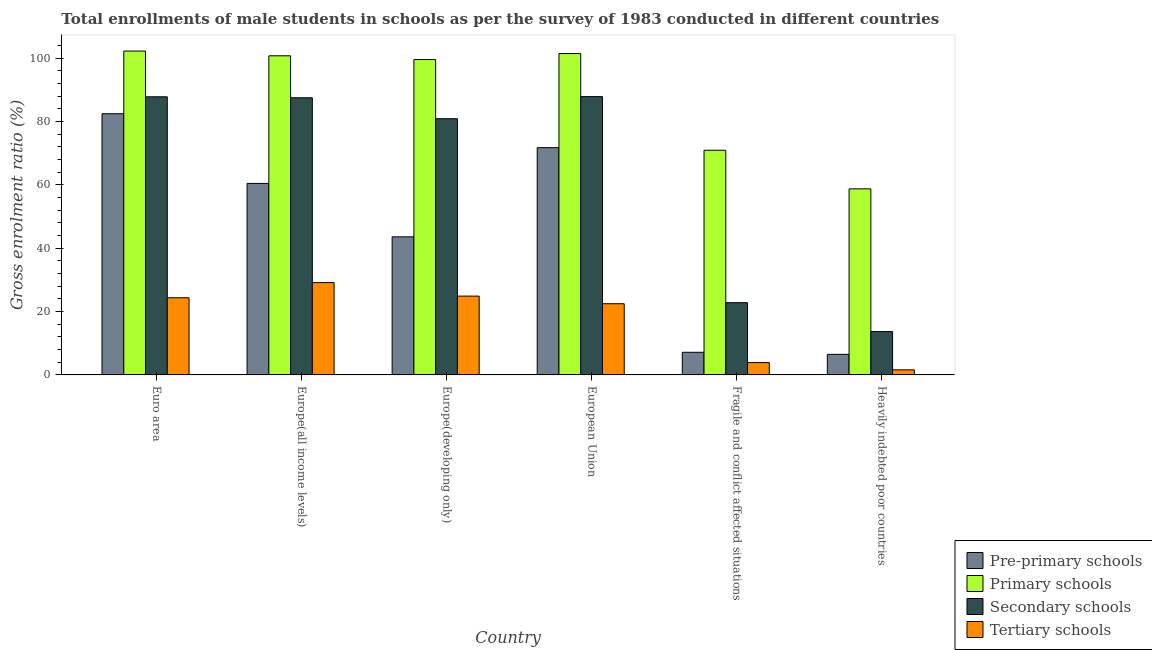How many different coloured bars are there?
Keep it short and to the point. 4. How many groups of bars are there?
Provide a succinct answer. 6. Are the number of bars on each tick of the X-axis equal?
Provide a short and direct response. Yes. How many bars are there on the 2nd tick from the left?
Provide a short and direct response. 4. What is the gross enrolment ratio(male) in pre-primary schools in Europe(all income levels)?
Provide a short and direct response. 60.44. Across all countries, what is the maximum gross enrolment ratio(male) in tertiary schools?
Provide a short and direct response. 29.13. Across all countries, what is the minimum gross enrolment ratio(male) in secondary schools?
Provide a short and direct response. 13.68. In which country was the gross enrolment ratio(male) in pre-primary schools maximum?
Ensure brevity in your answer.  Euro area. In which country was the gross enrolment ratio(male) in tertiary schools minimum?
Offer a very short reply. Heavily indebted poor countries. What is the total gross enrolment ratio(male) in primary schools in the graph?
Make the answer very short. 533.57. What is the difference between the gross enrolment ratio(male) in pre-primary schools in Euro area and that in Fragile and conflict affected situations?
Keep it short and to the point. 75.3. What is the difference between the gross enrolment ratio(male) in secondary schools in Euro area and the gross enrolment ratio(male) in primary schools in Europe(all income levels)?
Ensure brevity in your answer.  -12.94. What is the average gross enrolment ratio(male) in tertiary schools per country?
Your response must be concise. 17.72. What is the difference between the gross enrolment ratio(male) in secondary schools and gross enrolment ratio(male) in primary schools in Euro area?
Provide a succinct answer. -14.43. What is the ratio of the gross enrolment ratio(male) in secondary schools in Euro area to that in Fragile and conflict affected situations?
Your response must be concise. 3.85. What is the difference between the highest and the second highest gross enrolment ratio(male) in tertiary schools?
Offer a very short reply. 4.26. What is the difference between the highest and the lowest gross enrolment ratio(male) in secondary schools?
Give a very brief answer. 74.16. What does the 3rd bar from the left in Euro area represents?
Give a very brief answer. Secondary schools. What does the 4th bar from the right in Heavily indebted poor countries represents?
Keep it short and to the point. Pre-primary schools. How many bars are there?
Give a very brief answer. 24. Are all the bars in the graph horizontal?
Offer a very short reply. No. What is the difference between two consecutive major ticks on the Y-axis?
Keep it short and to the point. 20. Are the values on the major ticks of Y-axis written in scientific E-notation?
Give a very brief answer. No. Does the graph contain any zero values?
Give a very brief answer. No. Does the graph contain grids?
Your response must be concise. No. Where does the legend appear in the graph?
Your answer should be very brief. Bottom right. How many legend labels are there?
Your answer should be very brief. 4. What is the title of the graph?
Ensure brevity in your answer.  Total enrollments of male students in schools as per the survey of 1983 conducted in different countries. What is the label or title of the X-axis?
Provide a succinct answer. Country. What is the Gross enrolment ratio (%) of Pre-primary schools in Euro area?
Give a very brief answer. 82.45. What is the Gross enrolment ratio (%) of Primary schools in Euro area?
Make the answer very short. 102.22. What is the Gross enrolment ratio (%) of Secondary schools in Euro area?
Offer a very short reply. 87.79. What is the Gross enrolment ratio (%) in Tertiary schools in Euro area?
Your response must be concise. 24.35. What is the Gross enrolment ratio (%) of Pre-primary schools in Europe(all income levels)?
Keep it short and to the point. 60.44. What is the Gross enrolment ratio (%) of Primary schools in Europe(all income levels)?
Your answer should be very brief. 100.73. What is the Gross enrolment ratio (%) of Secondary schools in Europe(all income levels)?
Offer a terse response. 87.47. What is the Gross enrolment ratio (%) of Tertiary schools in Europe(all income levels)?
Provide a succinct answer. 29.13. What is the Gross enrolment ratio (%) of Pre-primary schools in Europe(developing only)?
Give a very brief answer. 43.58. What is the Gross enrolment ratio (%) of Primary schools in Europe(developing only)?
Make the answer very short. 99.54. What is the Gross enrolment ratio (%) of Secondary schools in Europe(developing only)?
Give a very brief answer. 80.87. What is the Gross enrolment ratio (%) of Tertiary schools in Europe(developing only)?
Ensure brevity in your answer.  24.88. What is the Gross enrolment ratio (%) of Pre-primary schools in European Union?
Make the answer very short. 71.73. What is the Gross enrolment ratio (%) of Primary schools in European Union?
Provide a succinct answer. 101.43. What is the Gross enrolment ratio (%) of Secondary schools in European Union?
Provide a short and direct response. 87.84. What is the Gross enrolment ratio (%) of Tertiary schools in European Union?
Your answer should be very brief. 22.47. What is the Gross enrolment ratio (%) of Pre-primary schools in Fragile and conflict affected situations?
Your response must be concise. 7.14. What is the Gross enrolment ratio (%) of Primary schools in Fragile and conflict affected situations?
Ensure brevity in your answer.  70.91. What is the Gross enrolment ratio (%) of Secondary schools in Fragile and conflict affected situations?
Make the answer very short. 22.8. What is the Gross enrolment ratio (%) of Tertiary schools in Fragile and conflict affected situations?
Offer a terse response. 3.89. What is the Gross enrolment ratio (%) in Pre-primary schools in Heavily indebted poor countries?
Offer a very short reply. 6.49. What is the Gross enrolment ratio (%) in Primary schools in Heavily indebted poor countries?
Your answer should be compact. 58.73. What is the Gross enrolment ratio (%) in Secondary schools in Heavily indebted poor countries?
Your response must be concise. 13.68. What is the Gross enrolment ratio (%) of Tertiary schools in Heavily indebted poor countries?
Give a very brief answer. 1.6. Across all countries, what is the maximum Gross enrolment ratio (%) of Pre-primary schools?
Provide a short and direct response. 82.45. Across all countries, what is the maximum Gross enrolment ratio (%) in Primary schools?
Ensure brevity in your answer.  102.22. Across all countries, what is the maximum Gross enrolment ratio (%) in Secondary schools?
Your answer should be compact. 87.84. Across all countries, what is the maximum Gross enrolment ratio (%) of Tertiary schools?
Provide a short and direct response. 29.13. Across all countries, what is the minimum Gross enrolment ratio (%) in Pre-primary schools?
Keep it short and to the point. 6.49. Across all countries, what is the minimum Gross enrolment ratio (%) of Primary schools?
Offer a very short reply. 58.73. Across all countries, what is the minimum Gross enrolment ratio (%) in Secondary schools?
Keep it short and to the point. 13.68. Across all countries, what is the minimum Gross enrolment ratio (%) of Tertiary schools?
Make the answer very short. 1.6. What is the total Gross enrolment ratio (%) of Pre-primary schools in the graph?
Offer a terse response. 271.83. What is the total Gross enrolment ratio (%) in Primary schools in the graph?
Offer a terse response. 533.57. What is the total Gross enrolment ratio (%) of Secondary schools in the graph?
Provide a short and direct response. 380.45. What is the total Gross enrolment ratio (%) of Tertiary schools in the graph?
Offer a terse response. 106.33. What is the difference between the Gross enrolment ratio (%) in Pre-primary schools in Euro area and that in Europe(all income levels)?
Give a very brief answer. 22. What is the difference between the Gross enrolment ratio (%) in Primary schools in Euro area and that in Europe(all income levels)?
Provide a short and direct response. 1.49. What is the difference between the Gross enrolment ratio (%) of Secondary schools in Euro area and that in Europe(all income levels)?
Keep it short and to the point. 0.31. What is the difference between the Gross enrolment ratio (%) of Tertiary schools in Euro area and that in Europe(all income levels)?
Keep it short and to the point. -4.78. What is the difference between the Gross enrolment ratio (%) of Pre-primary schools in Euro area and that in Europe(developing only)?
Offer a terse response. 38.86. What is the difference between the Gross enrolment ratio (%) of Primary schools in Euro area and that in Europe(developing only)?
Offer a terse response. 2.67. What is the difference between the Gross enrolment ratio (%) of Secondary schools in Euro area and that in Europe(developing only)?
Your answer should be compact. 6.92. What is the difference between the Gross enrolment ratio (%) in Tertiary schools in Euro area and that in Europe(developing only)?
Your answer should be compact. -0.52. What is the difference between the Gross enrolment ratio (%) in Pre-primary schools in Euro area and that in European Union?
Give a very brief answer. 10.72. What is the difference between the Gross enrolment ratio (%) in Primary schools in Euro area and that in European Union?
Offer a very short reply. 0.78. What is the difference between the Gross enrolment ratio (%) of Secondary schools in Euro area and that in European Union?
Offer a very short reply. -0.05. What is the difference between the Gross enrolment ratio (%) in Tertiary schools in Euro area and that in European Union?
Offer a very short reply. 1.88. What is the difference between the Gross enrolment ratio (%) of Pre-primary schools in Euro area and that in Fragile and conflict affected situations?
Provide a succinct answer. 75.3. What is the difference between the Gross enrolment ratio (%) in Primary schools in Euro area and that in Fragile and conflict affected situations?
Offer a very short reply. 31.31. What is the difference between the Gross enrolment ratio (%) of Secondary schools in Euro area and that in Fragile and conflict affected situations?
Ensure brevity in your answer.  64.98. What is the difference between the Gross enrolment ratio (%) in Tertiary schools in Euro area and that in Fragile and conflict affected situations?
Provide a succinct answer. 20.46. What is the difference between the Gross enrolment ratio (%) in Pre-primary schools in Euro area and that in Heavily indebted poor countries?
Your response must be concise. 75.95. What is the difference between the Gross enrolment ratio (%) in Primary schools in Euro area and that in Heavily indebted poor countries?
Your response must be concise. 43.49. What is the difference between the Gross enrolment ratio (%) in Secondary schools in Euro area and that in Heavily indebted poor countries?
Offer a very short reply. 74.11. What is the difference between the Gross enrolment ratio (%) of Tertiary schools in Euro area and that in Heavily indebted poor countries?
Give a very brief answer. 22.75. What is the difference between the Gross enrolment ratio (%) of Pre-primary schools in Europe(all income levels) and that in Europe(developing only)?
Provide a short and direct response. 16.86. What is the difference between the Gross enrolment ratio (%) of Primary schools in Europe(all income levels) and that in Europe(developing only)?
Keep it short and to the point. 1.19. What is the difference between the Gross enrolment ratio (%) in Secondary schools in Europe(all income levels) and that in Europe(developing only)?
Your response must be concise. 6.61. What is the difference between the Gross enrolment ratio (%) in Tertiary schools in Europe(all income levels) and that in Europe(developing only)?
Your answer should be very brief. 4.26. What is the difference between the Gross enrolment ratio (%) of Pre-primary schools in Europe(all income levels) and that in European Union?
Make the answer very short. -11.28. What is the difference between the Gross enrolment ratio (%) of Primary schools in Europe(all income levels) and that in European Union?
Ensure brevity in your answer.  -0.7. What is the difference between the Gross enrolment ratio (%) of Secondary schools in Europe(all income levels) and that in European Union?
Offer a terse response. -0.37. What is the difference between the Gross enrolment ratio (%) in Tertiary schools in Europe(all income levels) and that in European Union?
Your response must be concise. 6.66. What is the difference between the Gross enrolment ratio (%) in Pre-primary schools in Europe(all income levels) and that in Fragile and conflict affected situations?
Ensure brevity in your answer.  53.3. What is the difference between the Gross enrolment ratio (%) in Primary schools in Europe(all income levels) and that in Fragile and conflict affected situations?
Give a very brief answer. 29.82. What is the difference between the Gross enrolment ratio (%) of Secondary schools in Europe(all income levels) and that in Fragile and conflict affected situations?
Ensure brevity in your answer.  64.67. What is the difference between the Gross enrolment ratio (%) of Tertiary schools in Europe(all income levels) and that in Fragile and conflict affected situations?
Your answer should be compact. 25.25. What is the difference between the Gross enrolment ratio (%) in Pre-primary schools in Europe(all income levels) and that in Heavily indebted poor countries?
Keep it short and to the point. 53.95. What is the difference between the Gross enrolment ratio (%) in Primary schools in Europe(all income levels) and that in Heavily indebted poor countries?
Offer a very short reply. 42. What is the difference between the Gross enrolment ratio (%) of Secondary schools in Europe(all income levels) and that in Heavily indebted poor countries?
Make the answer very short. 73.79. What is the difference between the Gross enrolment ratio (%) of Tertiary schools in Europe(all income levels) and that in Heavily indebted poor countries?
Make the answer very short. 27.53. What is the difference between the Gross enrolment ratio (%) of Pre-primary schools in Europe(developing only) and that in European Union?
Offer a very short reply. -28.14. What is the difference between the Gross enrolment ratio (%) of Primary schools in Europe(developing only) and that in European Union?
Offer a terse response. -1.89. What is the difference between the Gross enrolment ratio (%) in Secondary schools in Europe(developing only) and that in European Union?
Provide a succinct answer. -6.97. What is the difference between the Gross enrolment ratio (%) in Tertiary schools in Europe(developing only) and that in European Union?
Keep it short and to the point. 2.41. What is the difference between the Gross enrolment ratio (%) in Pre-primary schools in Europe(developing only) and that in Fragile and conflict affected situations?
Keep it short and to the point. 36.44. What is the difference between the Gross enrolment ratio (%) in Primary schools in Europe(developing only) and that in Fragile and conflict affected situations?
Offer a terse response. 28.63. What is the difference between the Gross enrolment ratio (%) of Secondary schools in Europe(developing only) and that in Fragile and conflict affected situations?
Your response must be concise. 58.07. What is the difference between the Gross enrolment ratio (%) of Tertiary schools in Europe(developing only) and that in Fragile and conflict affected situations?
Your response must be concise. 20.99. What is the difference between the Gross enrolment ratio (%) of Pre-primary schools in Europe(developing only) and that in Heavily indebted poor countries?
Give a very brief answer. 37.09. What is the difference between the Gross enrolment ratio (%) in Primary schools in Europe(developing only) and that in Heavily indebted poor countries?
Make the answer very short. 40.82. What is the difference between the Gross enrolment ratio (%) of Secondary schools in Europe(developing only) and that in Heavily indebted poor countries?
Your answer should be very brief. 67.19. What is the difference between the Gross enrolment ratio (%) of Tertiary schools in Europe(developing only) and that in Heavily indebted poor countries?
Your answer should be compact. 23.27. What is the difference between the Gross enrolment ratio (%) of Pre-primary schools in European Union and that in Fragile and conflict affected situations?
Offer a terse response. 64.58. What is the difference between the Gross enrolment ratio (%) in Primary schools in European Union and that in Fragile and conflict affected situations?
Give a very brief answer. 30.52. What is the difference between the Gross enrolment ratio (%) of Secondary schools in European Union and that in Fragile and conflict affected situations?
Make the answer very short. 65.04. What is the difference between the Gross enrolment ratio (%) of Tertiary schools in European Union and that in Fragile and conflict affected situations?
Your answer should be compact. 18.58. What is the difference between the Gross enrolment ratio (%) in Pre-primary schools in European Union and that in Heavily indebted poor countries?
Offer a terse response. 65.24. What is the difference between the Gross enrolment ratio (%) in Primary schools in European Union and that in Heavily indebted poor countries?
Make the answer very short. 42.71. What is the difference between the Gross enrolment ratio (%) of Secondary schools in European Union and that in Heavily indebted poor countries?
Your answer should be very brief. 74.16. What is the difference between the Gross enrolment ratio (%) of Tertiary schools in European Union and that in Heavily indebted poor countries?
Ensure brevity in your answer.  20.87. What is the difference between the Gross enrolment ratio (%) in Pre-primary schools in Fragile and conflict affected situations and that in Heavily indebted poor countries?
Your answer should be very brief. 0.65. What is the difference between the Gross enrolment ratio (%) of Primary schools in Fragile and conflict affected situations and that in Heavily indebted poor countries?
Keep it short and to the point. 12.18. What is the difference between the Gross enrolment ratio (%) of Secondary schools in Fragile and conflict affected situations and that in Heavily indebted poor countries?
Give a very brief answer. 9.12. What is the difference between the Gross enrolment ratio (%) in Tertiary schools in Fragile and conflict affected situations and that in Heavily indebted poor countries?
Provide a short and direct response. 2.28. What is the difference between the Gross enrolment ratio (%) in Pre-primary schools in Euro area and the Gross enrolment ratio (%) in Primary schools in Europe(all income levels)?
Provide a short and direct response. -18.29. What is the difference between the Gross enrolment ratio (%) of Pre-primary schools in Euro area and the Gross enrolment ratio (%) of Secondary schools in Europe(all income levels)?
Give a very brief answer. -5.03. What is the difference between the Gross enrolment ratio (%) of Pre-primary schools in Euro area and the Gross enrolment ratio (%) of Tertiary schools in Europe(all income levels)?
Provide a succinct answer. 53.31. What is the difference between the Gross enrolment ratio (%) in Primary schools in Euro area and the Gross enrolment ratio (%) in Secondary schools in Europe(all income levels)?
Your answer should be very brief. 14.74. What is the difference between the Gross enrolment ratio (%) of Primary schools in Euro area and the Gross enrolment ratio (%) of Tertiary schools in Europe(all income levels)?
Offer a very short reply. 73.08. What is the difference between the Gross enrolment ratio (%) in Secondary schools in Euro area and the Gross enrolment ratio (%) in Tertiary schools in Europe(all income levels)?
Offer a very short reply. 58.65. What is the difference between the Gross enrolment ratio (%) of Pre-primary schools in Euro area and the Gross enrolment ratio (%) of Primary schools in Europe(developing only)?
Your response must be concise. -17.1. What is the difference between the Gross enrolment ratio (%) of Pre-primary schools in Euro area and the Gross enrolment ratio (%) of Secondary schools in Europe(developing only)?
Offer a very short reply. 1.58. What is the difference between the Gross enrolment ratio (%) of Pre-primary schools in Euro area and the Gross enrolment ratio (%) of Tertiary schools in Europe(developing only)?
Your answer should be very brief. 57.57. What is the difference between the Gross enrolment ratio (%) in Primary schools in Euro area and the Gross enrolment ratio (%) in Secondary schools in Europe(developing only)?
Offer a terse response. 21.35. What is the difference between the Gross enrolment ratio (%) in Primary schools in Euro area and the Gross enrolment ratio (%) in Tertiary schools in Europe(developing only)?
Your response must be concise. 77.34. What is the difference between the Gross enrolment ratio (%) of Secondary schools in Euro area and the Gross enrolment ratio (%) of Tertiary schools in Europe(developing only)?
Provide a succinct answer. 62.91. What is the difference between the Gross enrolment ratio (%) in Pre-primary schools in Euro area and the Gross enrolment ratio (%) in Primary schools in European Union?
Your answer should be compact. -18.99. What is the difference between the Gross enrolment ratio (%) of Pre-primary schools in Euro area and the Gross enrolment ratio (%) of Secondary schools in European Union?
Provide a succinct answer. -5.39. What is the difference between the Gross enrolment ratio (%) of Pre-primary schools in Euro area and the Gross enrolment ratio (%) of Tertiary schools in European Union?
Your answer should be compact. 59.97. What is the difference between the Gross enrolment ratio (%) of Primary schools in Euro area and the Gross enrolment ratio (%) of Secondary schools in European Union?
Your answer should be very brief. 14.38. What is the difference between the Gross enrolment ratio (%) of Primary schools in Euro area and the Gross enrolment ratio (%) of Tertiary schools in European Union?
Give a very brief answer. 79.75. What is the difference between the Gross enrolment ratio (%) of Secondary schools in Euro area and the Gross enrolment ratio (%) of Tertiary schools in European Union?
Make the answer very short. 65.31. What is the difference between the Gross enrolment ratio (%) of Pre-primary schools in Euro area and the Gross enrolment ratio (%) of Primary schools in Fragile and conflict affected situations?
Make the answer very short. 11.53. What is the difference between the Gross enrolment ratio (%) of Pre-primary schools in Euro area and the Gross enrolment ratio (%) of Secondary schools in Fragile and conflict affected situations?
Give a very brief answer. 59.64. What is the difference between the Gross enrolment ratio (%) of Pre-primary schools in Euro area and the Gross enrolment ratio (%) of Tertiary schools in Fragile and conflict affected situations?
Your response must be concise. 78.56. What is the difference between the Gross enrolment ratio (%) of Primary schools in Euro area and the Gross enrolment ratio (%) of Secondary schools in Fragile and conflict affected situations?
Ensure brevity in your answer.  79.42. What is the difference between the Gross enrolment ratio (%) of Primary schools in Euro area and the Gross enrolment ratio (%) of Tertiary schools in Fragile and conflict affected situations?
Your answer should be very brief. 98.33. What is the difference between the Gross enrolment ratio (%) in Secondary schools in Euro area and the Gross enrolment ratio (%) in Tertiary schools in Fragile and conflict affected situations?
Give a very brief answer. 83.9. What is the difference between the Gross enrolment ratio (%) of Pre-primary schools in Euro area and the Gross enrolment ratio (%) of Primary schools in Heavily indebted poor countries?
Offer a very short reply. 23.72. What is the difference between the Gross enrolment ratio (%) in Pre-primary schools in Euro area and the Gross enrolment ratio (%) in Secondary schools in Heavily indebted poor countries?
Make the answer very short. 68.77. What is the difference between the Gross enrolment ratio (%) in Pre-primary schools in Euro area and the Gross enrolment ratio (%) in Tertiary schools in Heavily indebted poor countries?
Your answer should be compact. 80.84. What is the difference between the Gross enrolment ratio (%) in Primary schools in Euro area and the Gross enrolment ratio (%) in Secondary schools in Heavily indebted poor countries?
Give a very brief answer. 88.54. What is the difference between the Gross enrolment ratio (%) of Primary schools in Euro area and the Gross enrolment ratio (%) of Tertiary schools in Heavily indebted poor countries?
Provide a succinct answer. 100.61. What is the difference between the Gross enrolment ratio (%) in Secondary schools in Euro area and the Gross enrolment ratio (%) in Tertiary schools in Heavily indebted poor countries?
Provide a short and direct response. 86.18. What is the difference between the Gross enrolment ratio (%) of Pre-primary schools in Europe(all income levels) and the Gross enrolment ratio (%) of Primary schools in Europe(developing only)?
Offer a very short reply. -39.1. What is the difference between the Gross enrolment ratio (%) of Pre-primary schools in Europe(all income levels) and the Gross enrolment ratio (%) of Secondary schools in Europe(developing only)?
Your response must be concise. -20.42. What is the difference between the Gross enrolment ratio (%) of Pre-primary schools in Europe(all income levels) and the Gross enrolment ratio (%) of Tertiary schools in Europe(developing only)?
Your answer should be compact. 35.57. What is the difference between the Gross enrolment ratio (%) of Primary schools in Europe(all income levels) and the Gross enrolment ratio (%) of Secondary schools in Europe(developing only)?
Offer a terse response. 19.86. What is the difference between the Gross enrolment ratio (%) of Primary schools in Europe(all income levels) and the Gross enrolment ratio (%) of Tertiary schools in Europe(developing only)?
Ensure brevity in your answer.  75.85. What is the difference between the Gross enrolment ratio (%) in Secondary schools in Europe(all income levels) and the Gross enrolment ratio (%) in Tertiary schools in Europe(developing only)?
Your answer should be compact. 62.6. What is the difference between the Gross enrolment ratio (%) in Pre-primary schools in Europe(all income levels) and the Gross enrolment ratio (%) in Primary schools in European Union?
Offer a terse response. -40.99. What is the difference between the Gross enrolment ratio (%) of Pre-primary schools in Europe(all income levels) and the Gross enrolment ratio (%) of Secondary schools in European Union?
Provide a short and direct response. -27.39. What is the difference between the Gross enrolment ratio (%) of Pre-primary schools in Europe(all income levels) and the Gross enrolment ratio (%) of Tertiary schools in European Union?
Offer a terse response. 37.97. What is the difference between the Gross enrolment ratio (%) in Primary schools in Europe(all income levels) and the Gross enrolment ratio (%) in Secondary schools in European Union?
Provide a succinct answer. 12.89. What is the difference between the Gross enrolment ratio (%) of Primary schools in Europe(all income levels) and the Gross enrolment ratio (%) of Tertiary schools in European Union?
Ensure brevity in your answer.  78.26. What is the difference between the Gross enrolment ratio (%) of Secondary schools in Europe(all income levels) and the Gross enrolment ratio (%) of Tertiary schools in European Union?
Offer a very short reply. 65. What is the difference between the Gross enrolment ratio (%) in Pre-primary schools in Europe(all income levels) and the Gross enrolment ratio (%) in Primary schools in Fragile and conflict affected situations?
Give a very brief answer. -10.47. What is the difference between the Gross enrolment ratio (%) of Pre-primary schools in Europe(all income levels) and the Gross enrolment ratio (%) of Secondary schools in Fragile and conflict affected situations?
Provide a succinct answer. 37.64. What is the difference between the Gross enrolment ratio (%) in Pre-primary schools in Europe(all income levels) and the Gross enrolment ratio (%) in Tertiary schools in Fragile and conflict affected situations?
Provide a succinct answer. 56.56. What is the difference between the Gross enrolment ratio (%) in Primary schools in Europe(all income levels) and the Gross enrolment ratio (%) in Secondary schools in Fragile and conflict affected situations?
Provide a short and direct response. 77.93. What is the difference between the Gross enrolment ratio (%) in Primary schools in Europe(all income levels) and the Gross enrolment ratio (%) in Tertiary schools in Fragile and conflict affected situations?
Your answer should be very brief. 96.84. What is the difference between the Gross enrolment ratio (%) in Secondary schools in Europe(all income levels) and the Gross enrolment ratio (%) in Tertiary schools in Fragile and conflict affected situations?
Your response must be concise. 83.58. What is the difference between the Gross enrolment ratio (%) of Pre-primary schools in Europe(all income levels) and the Gross enrolment ratio (%) of Primary schools in Heavily indebted poor countries?
Offer a terse response. 1.72. What is the difference between the Gross enrolment ratio (%) of Pre-primary schools in Europe(all income levels) and the Gross enrolment ratio (%) of Secondary schools in Heavily indebted poor countries?
Make the answer very short. 46.76. What is the difference between the Gross enrolment ratio (%) in Pre-primary schools in Europe(all income levels) and the Gross enrolment ratio (%) in Tertiary schools in Heavily indebted poor countries?
Offer a terse response. 58.84. What is the difference between the Gross enrolment ratio (%) of Primary schools in Europe(all income levels) and the Gross enrolment ratio (%) of Secondary schools in Heavily indebted poor countries?
Provide a short and direct response. 87.05. What is the difference between the Gross enrolment ratio (%) of Primary schools in Europe(all income levels) and the Gross enrolment ratio (%) of Tertiary schools in Heavily indebted poor countries?
Offer a very short reply. 99.13. What is the difference between the Gross enrolment ratio (%) of Secondary schools in Europe(all income levels) and the Gross enrolment ratio (%) of Tertiary schools in Heavily indebted poor countries?
Ensure brevity in your answer.  85.87. What is the difference between the Gross enrolment ratio (%) in Pre-primary schools in Europe(developing only) and the Gross enrolment ratio (%) in Primary schools in European Union?
Offer a very short reply. -57.85. What is the difference between the Gross enrolment ratio (%) in Pre-primary schools in Europe(developing only) and the Gross enrolment ratio (%) in Secondary schools in European Union?
Provide a succinct answer. -44.26. What is the difference between the Gross enrolment ratio (%) in Pre-primary schools in Europe(developing only) and the Gross enrolment ratio (%) in Tertiary schools in European Union?
Your answer should be compact. 21.11. What is the difference between the Gross enrolment ratio (%) of Primary schools in Europe(developing only) and the Gross enrolment ratio (%) of Secondary schools in European Union?
Provide a succinct answer. 11.7. What is the difference between the Gross enrolment ratio (%) in Primary schools in Europe(developing only) and the Gross enrolment ratio (%) in Tertiary schools in European Union?
Provide a succinct answer. 77.07. What is the difference between the Gross enrolment ratio (%) of Secondary schools in Europe(developing only) and the Gross enrolment ratio (%) of Tertiary schools in European Union?
Your answer should be very brief. 58.4. What is the difference between the Gross enrolment ratio (%) of Pre-primary schools in Europe(developing only) and the Gross enrolment ratio (%) of Primary schools in Fragile and conflict affected situations?
Your answer should be compact. -27.33. What is the difference between the Gross enrolment ratio (%) of Pre-primary schools in Europe(developing only) and the Gross enrolment ratio (%) of Secondary schools in Fragile and conflict affected situations?
Ensure brevity in your answer.  20.78. What is the difference between the Gross enrolment ratio (%) of Pre-primary schools in Europe(developing only) and the Gross enrolment ratio (%) of Tertiary schools in Fragile and conflict affected situations?
Provide a succinct answer. 39.69. What is the difference between the Gross enrolment ratio (%) of Primary schools in Europe(developing only) and the Gross enrolment ratio (%) of Secondary schools in Fragile and conflict affected situations?
Offer a very short reply. 76.74. What is the difference between the Gross enrolment ratio (%) of Primary schools in Europe(developing only) and the Gross enrolment ratio (%) of Tertiary schools in Fragile and conflict affected situations?
Provide a short and direct response. 95.66. What is the difference between the Gross enrolment ratio (%) in Secondary schools in Europe(developing only) and the Gross enrolment ratio (%) in Tertiary schools in Fragile and conflict affected situations?
Provide a short and direct response. 76.98. What is the difference between the Gross enrolment ratio (%) of Pre-primary schools in Europe(developing only) and the Gross enrolment ratio (%) of Primary schools in Heavily indebted poor countries?
Offer a very short reply. -15.15. What is the difference between the Gross enrolment ratio (%) in Pre-primary schools in Europe(developing only) and the Gross enrolment ratio (%) in Secondary schools in Heavily indebted poor countries?
Provide a short and direct response. 29.9. What is the difference between the Gross enrolment ratio (%) of Pre-primary schools in Europe(developing only) and the Gross enrolment ratio (%) of Tertiary schools in Heavily indebted poor countries?
Offer a very short reply. 41.98. What is the difference between the Gross enrolment ratio (%) in Primary schools in Europe(developing only) and the Gross enrolment ratio (%) in Secondary schools in Heavily indebted poor countries?
Your answer should be compact. 85.86. What is the difference between the Gross enrolment ratio (%) in Primary schools in Europe(developing only) and the Gross enrolment ratio (%) in Tertiary schools in Heavily indebted poor countries?
Your answer should be very brief. 97.94. What is the difference between the Gross enrolment ratio (%) of Secondary schools in Europe(developing only) and the Gross enrolment ratio (%) of Tertiary schools in Heavily indebted poor countries?
Give a very brief answer. 79.26. What is the difference between the Gross enrolment ratio (%) in Pre-primary schools in European Union and the Gross enrolment ratio (%) in Primary schools in Fragile and conflict affected situations?
Your answer should be very brief. 0.82. What is the difference between the Gross enrolment ratio (%) of Pre-primary schools in European Union and the Gross enrolment ratio (%) of Secondary schools in Fragile and conflict affected situations?
Offer a very short reply. 48.93. What is the difference between the Gross enrolment ratio (%) in Pre-primary schools in European Union and the Gross enrolment ratio (%) in Tertiary schools in Fragile and conflict affected situations?
Offer a very short reply. 67.84. What is the difference between the Gross enrolment ratio (%) of Primary schools in European Union and the Gross enrolment ratio (%) of Secondary schools in Fragile and conflict affected situations?
Give a very brief answer. 78.63. What is the difference between the Gross enrolment ratio (%) of Primary schools in European Union and the Gross enrolment ratio (%) of Tertiary schools in Fragile and conflict affected situations?
Provide a short and direct response. 97.55. What is the difference between the Gross enrolment ratio (%) in Secondary schools in European Union and the Gross enrolment ratio (%) in Tertiary schools in Fragile and conflict affected situations?
Make the answer very short. 83.95. What is the difference between the Gross enrolment ratio (%) in Pre-primary schools in European Union and the Gross enrolment ratio (%) in Primary schools in Heavily indebted poor countries?
Your answer should be very brief. 13. What is the difference between the Gross enrolment ratio (%) in Pre-primary schools in European Union and the Gross enrolment ratio (%) in Secondary schools in Heavily indebted poor countries?
Your answer should be very brief. 58.05. What is the difference between the Gross enrolment ratio (%) in Pre-primary schools in European Union and the Gross enrolment ratio (%) in Tertiary schools in Heavily indebted poor countries?
Your response must be concise. 70.12. What is the difference between the Gross enrolment ratio (%) in Primary schools in European Union and the Gross enrolment ratio (%) in Secondary schools in Heavily indebted poor countries?
Provide a short and direct response. 87.75. What is the difference between the Gross enrolment ratio (%) of Primary schools in European Union and the Gross enrolment ratio (%) of Tertiary schools in Heavily indebted poor countries?
Give a very brief answer. 99.83. What is the difference between the Gross enrolment ratio (%) in Secondary schools in European Union and the Gross enrolment ratio (%) in Tertiary schools in Heavily indebted poor countries?
Ensure brevity in your answer.  86.24. What is the difference between the Gross enrolment ratio (%) of Pre-primary schools in Fragile and conflict affected situations and the Gross enrolment ratio (%) of Primary schools in Heavily indebted poor countries?
Provide a short and direct response. -51.59. What is the difference between the Gross enrolment ratio (%) of Pre-primary schools in Fragile and conflict affected situations and the Gross enrolment ratio (%) of Secondary schools in Heavily indebted poor countries?
Your response must be concise. -6.54. What is the difference between the Gross enrolment ratio (%) in Pre-primary schools in Fragile and conflict affected situations and the Gross enrolment ratio (%) in Tertiary schools in Heavily indebted poor countries?
Make the answer very short. 5.54. What is the difference between the Gross enrolment ratio (%) of Primary schools in Fragile and conflict affected situations and the Gross enrolment ratio (%) of Secondary schools in Heavily indebted poor countries?
Your response must be concise. 57.23. What is the difference between the Gross enrolment ratio (%) in Primary schools in Fragile and conflict affected situations and the Gross enrolment ratio (%) in Tertiary schools in Heavily indebted poor countries?
Give a very brief answer. 69.31. What is the difference between the Gross enrolment ratio (%) in Secondary schools in Fragile and conflict affected situations and the Gross enrolment ratio (%) in Tertiary schools in Heavily indebted poor countries?
Offer a terse response. 21.2. What is the average Gross enrolment ratio (%) of Pre-primary schools per country?
Provide a short and direct response. 45.31. What is the average Gross enrolment ratio (%) of Primary schools per country?
Offer a very short reply. 88.93. What is the average Gross enrolment ratio (%) of Secondary schools per country?
Your answer should be very brief. 63.41. What is the average Gross enrolment ratio (%) of Tertiary schools per country?
Your answer should be compact. 17.72. What is the difference between the Gross enrolment ratio (%) in Pre-primary schools and Gross enrolment ratio (%) in Primary schools in Euro area?
Your answer should be very brief. -19.77. What is the difference between the Gross enrolment ratio (%) in Pre-primary schools and Gross enrolment ratio (%) in Secondary schools in Euro area?
Ensure brevity in your answer.  -5.34. What is the difference between the Gross enrolment ratio (%) in Pre-primary schools and Gross enrolment ratio (%) in Tertiary schools in Euro area?
Ensure brevity in your answer.  58.09. What is the difference between the Gross enrolment ratio (%) in Primary schools and Gross enrolment ratio (%) in Secondary schools in Euro area?
Your answer should be compact. 14.43. What is the difference between the Gross enrolment ratio (%) of Primary schools and Gross enrolment ratio (%) of Tertiary schools in Euro area?
Ensure brevity in your answer.  77.87. What is the difference between the Gross enrolment ratio (%) of Secondary schools and Gross enrolment ratio (%) of Tertiary schools in Euro area?
Offer a very short reply. 63.43. What is the difference between the Gross enrolment ratio (%) in Pre-primary schools and Gross enrolment ratio (%) in Primary schools in Europe(all income levels)?
Your answer should be compact. -40.29. What is the difference between the Gross enrolment ratio (%) of Pre-primary schools and Gross enrolment ratio (%) of Secondary schools in Europe(all income levels)?
Offer a very short reply. -27.03. What is the difference between the Gross enrolment ratio (%) in Pre-primary schools and Gross enrolment ratio (%) in Tertiary schools in Europe(all income levels)?
Provide a succinct answer. 31.31. What is the difference between the Gross enrolment ratio (%) in Primary schools and Gross enrolment ratio (%) in Secondary schools in Europe(all income levels)?
Ensure brevity in your answer.  13.26. What is the difference between the Gross enrolment ratio (%) of Primary schools and Gross enrolment ratio (%) of Tertiary schools in Europe(all income levels)?
Give a very brief answer. 71.6. What is the difference between the Gross enrolment ratio (%) of Secondary schools and Gross enrolment ratio (%) of Tertiary schools in Europe(all income levels)?
Keep it short and to the point. 58.34. What is the difference between the Gross enrolment ratio (%) of Pre-primary schools and Gross enrolment ratio (%) of Primary schools in Europe(developing only)?
Provide a short and direct response. -55.96. What is the difference between the Gross enrolment ratio (%) in Pre-primary schools and Gross enrolment ratio (%) in Secondary schools in Europe(developing only)?
Your answer should be very brief. -37.29. What is the difference between the Gross enrolment ratio (%) of Pre-primary schools and Gross enrolment ratio (%) of Tertiary schools in Europe(developing only)?
Offer a very short reply. 18.71. What is the difference between the Gross enrolment ratio (%) in Primary schools and Gross enrolment ratio (%) in Secondary schools in Europe(developing only)?
Give a very brief answer. 18.68. What is the difference between the Gross enrolment ratio (%) of Primary schools and Gross enrolment ratio (%) of Tertiary schools in Europe(developing only)?
Your response must be concise. 74.67. What is the difference between the Gross enrolment ratio (%) of Secondary schools and Gross enrolment ratio (%) of Tertiary schools in Europe(developing only)?
Provide a short and direct response. 55.99. What is the difference between the Gross enrolment ratio (%) of Pre-primary schools and Gross enrolment ratio (%) of Primary schools in European Union?
Ensure brevity in your answer.  -29.71. What is the difference between the Gross enrolment ratio (%) in Pre-primary schools and Gross enrolment ratio (%) in Secondary schools in European Union?
Offer a very short reply. -16.11. What is the difference between the Gross enrolment ratio (%) of Pre-primary schools and Gross enrolment ratio (%) of Tertiary schools in European Union?
Provide a short and direct response. 49.26. What is the difference between the Gross enrolment ratio (%) of Primary schools and Gross enrolment ratio (%) of Secondary schools in European Union?
Your response must be concise. 13.6. What is the difference between the Gross enrolment ratio (%) of Primary schools and Gross enrolment ratio (%) of Tertiary schools in European Union?
Your response must be concise. 78.96. What is the difference between the Gross enrolment ratio (%) in Secondary schools and Gross enrolment ratio (%) in Tertiary schools in European Union?
Keep it short and to the point. 65.37. What is the difference between the Gross enrolment ratio (%) in Pre-primary schools and Gross enrolment ratio (%) in Primary schools in Fragile and conflict affected situations?
Make the answer very short. -63.77. What is the difference between the Gross enrolment ratio (%) in Pre-primary schools and Gross enrolment ratio (%) in Secondary schools in Fragile and conflict affected situations?
Provide a succinct answer. -15.66. What is the difference between the Gross enrolment ratio (%) of Pre-primary schools and Gross enrolment ratio (%) of Tertiary schools in Fragile and conflict affected situations?
Ensure brevity in your answer.  3.25. What is the difference between the Gross enrolment ratio (%) in Primary schools and Gross enrolment ratio (%) in Secondary schools in Fragile and conflict affected situations?
Keep it short and to the point. 48.11. What is the difference between the Gross enrolment ratio (%) in Primary schools and Gross enrolment ratio (%) in Tertiary schools in Fragile and conflict affected situations?
Make the answer very short. 67.02. What is the difference between the Gross enrolment ratio (%) in Secondary schools and Gross enrolment ratio (%) in Tertiary schools in Fragile and conflict affected situations?
Provide a short and direct response. 18.91. What is the difference between the Gross enrolment ratio (%) of Pre-primary schools and Gross enrolment ratio (%) of Primary schools in Heavily indebted poor countries?
Your response must be concise. -52.24. What is the difference between the Gross enrolment ratio (%) of Pre-primary schools and Gross enrolment ratio (%) of Secondary schools in Heavily indebted poor countries?
Provide a short and direct response. -7.19. What is the difference between the Gross enrolment ratio (%) of Pre-primary schools and Gross enrolment ratio (%) of Tertiary schools in Heavily indebted poor countries?
Give a very brief answer. 4.89. What is the difference between the Gross enrolment ratio (%) in Primary schools and Gross enrolment ratio (%) in Secondary schools in Heavily indebted poor countries?
Provide a short and direct response. 45.05. What is the difference between the Gross enrolment ratio (%) in Primary schools and Gross enrolment ratio (%) in Tertiary schools in Heavily indebted poor countries?
Keep it short and to the point. 57.12. What is the difference between the Gross enrolment ratio (%) of Secondary schools and Gross enrolment ratio (%) of Tertiary schools in Heavily indebted poor countries?
Provide a short and direct response. 12.08. What is the ratio of the Gross enrolment ratio (%) of Pre-primary schools in Euro area to that in Europe(all income levels)?
Ensure brevity in your answer.  1.36. What is the ratio of the Gross enrolment ratio (%) in Primary schools in Euro area to that in Europe(all income levels)?
Your answer should be very brief. 1.01. What is the ratio of the Gross enrolment ratio (%) in Tertiary schools in Euro area to that in Europe(all income levels)?
Make the answer very short. 0.84. What is the ratio of the Gross enrolment ratio (%) in Pre-primary schools in Euro area to that in Europe(developing only)?
Provide a short and direct response. 1.89. What is the ratio of the Gross enrolment ratio (%) in Primary schools in Euro area to that in Europe(developing only)?
Make the answer very short. 1.03. What is the ratio of the Gross enrolment ratio (%) in Secondary schools in Euro area to that in Europe(developing only)?
Offer a terse response. 1.09. What is the ratio of the Gross enrolment ratio (%) in Tertiary schools in Euro area to that in Europe(developing only)?
Offer a terse response. 0.98. What is the ratio of the Gross enrolment ratio (%) of Pre-primary schools in Euro area to that in European Union?
Keep it short and to the point. 1.15. What is the ratio of the Gross enrolment ratio (%) of Primary schools in Euro area to that in European Union?
Make the answer very short. 1.01. What is the ratio of the Gross enrolment ratio (%) of Secondary schools in Euro area to that in European Union?
Keep it short and to the point. 1. What is the ratio of the Gross enrolment ratio (%) in Tertiary schools in Euro area to that in European Union?
Provide a short and direct response. 1.08. What is the ratio of the Gross enrolment ratio (%) of Pre-primary schools in Euro area to that in Fragile and conflict affected situations?
Your answer should be very brief. 11.54. What is the ratio of the Gross enrolment ratio (%) of Primary schools in Euro area to that in Fragile and conflict affected situations?
Provide a succinct answer. 1.44. What is the ratio of the Gross enrolment ratio (%) of Secondary schools in Euro area to that in Fragile and conflict affected situations?
Your answer should be very brief. 3.85. What is the ratio of the Gross enrolment ratio (%) in Tertiary schools in Euro area to that in Fragile and conflict affected situations?
Ensure brevity in your answer.  6.26. What is the ratio of the Gross enrolment ratio (%) in Pre-primary schools in Euro area to that in Heavily indebted poor countries?
Your response must be concise. 12.7. What is the ratio of the Gross enrolment ratio (%) of Primary schools in Euro area to that in Heavily indebted poor countries?
Your response must be concise. 1.74. What is the ratio of the Gross enrolment ratio (%) in Secondary schools in Euro area to that in Heavily indebted poor countries?
Offer a terse response. 6.42. What is the ratio of the Gross enrolment ratio (%) of Tertiary schools in Euro area to that in Heavily indebted poor countries?
Give a very brief answer. 15.18. What is the ratio of the Gross enrolment ratio (%) of Pre-primary schools in Europe(all income levels) to that in Europe(developing only)?
Offer a terse response. 1.39. What is the ratio of the Gross enrolment ratio (%) of Primary schools in Europe(all income levels) to that in Europe(developing only)?
Your answer should be very brief. 1.01. What is the ratio of the Gross enrolment ratio (%) of Secondary schools in Europe(all income levels) to that in Europe(developing only)?
Offer a terse response. 1.08. What is the ratio of the Gross enrolment ratio (%) in Tertiary schools in Europe(all income levels) to that in Europe(developing only)?
Make the answer very short. 1.17. What is the ratio of the Gross enrolment ratio (%) in Pre-primary schools in Europe(all income levels) to that in European Union?
Offer a very short reply. 0.84. What is the ratio of the Gross enrolment ratio (%) of Secondary schools in Europe(all income levels) to that in European Union?
Provide a short and direct response. 1. What is the ratio of the Gross enrolment ratio (%) in Tertiary schools in Europe(all income levels) to that in European Union?
Offer a very short reply. 1.3. What is the ratio of the Gross enrolment ratio (%) in Pre-primary schools in Europe(all income levels) to that in Fragile and conflict affected situations?
Keep it short and to the point. 8.46. What is the ratio of the Gross enrolment ratio (%) in Primary schools in Europe(all income levels) to that in Fragile and conflict affected situations?
Offer a terse response. 1.42. What is the ratio of the Gross enrolment ratio (%) in Secondary schools in Europe(all income levels) to that in Fragile and conflict affected situations?
Your answer should be very brief. 3.84. What is the ratio of the Gross enrolment ratio (%) of Tertiary schools in Europe(all income levels) to that in Fragile and conflict affected situations?
Provide a short and direct response. 7.49. What is the ratio of the Gross enrolment ratio (%) in Pre-primary schools in Europe(all income levels) to that in Heavily indebted poor countries?
Ensure brevity in your answer.  9.31. What is the ratio of the Gross enrolment ratio (%) in Primary schools in Europe(all income levels) to that in Heavily indebted poor countries?
Offer a very short reply. 1.72. What is the ratio of the Gross enrolment ratio (%) of Secondary schools in Europe(all income levels) to that in Heavily indebted poor countries?
Give a very brief answer. 6.39. What is the ratio of the Gross enrolment ratio (%) in Tertiary schools in Europe(all income levels) to that in Heavily indebted poor countries?
Your answer should be compact. 18.16. What is the ratio of the Gross enrolment ratio (%) of Pre-primary schools in Europe(developing only) to that in European Union?
Provide a succinct answer. 0.61. What is the ratio of the Gross enrolment ratio (%) in Primary schools in Europe(developing only) to that in European Union?
Give a very brief answer. 0.98. What is the ratio of the Gross enrolment ratio (%) in Secondary schools in Europe(developing only) to that in European Union?
Your response must be concise. 0.92. What is the ratio of the Gross enrolment ratio (%) of Tertiary schools in Europe(developing only) to that in European Union?
Your answer should be compact. 1.11. What is the ratio of the Gross enrolment ratio (%) of Pre-primary schools in Europe(developing only) to that in Fragile and conflict affected situations?
Make the answer very short. 6.1. What is the ratio of the Gross enrolment ratio (%) in Primary schools in Europe(developing only) to that in Fragile and conflict affected situations?
Offer a very short reply. 1.4. What is the ratio of the Gross enrolment ratio (%) of Secondary schools in Europe(developing only) to that in Fragile and conflict affected situations?
Offer a very short reply. 3.55. What is the ratio of the Gross enrolment ratio (%) of Tertiary schools in Europe(developing only) to that in Fragile and conflict affected situations?
Ensure brevity in your answer.  6.4. What is the ratio of the Gross enrolment ratio (%) of Pre-primary schools in Europe(developing only) to that in Heavily indebted poor countries?
Offer a terse response. 6.71. What is the ratio of the Gross enrolment ratio (%) of Primary schools in Europe(developing only) to that in Heavily indebted poor countries?
Make the answer very short. 1.7. What is the ratio of the Gross enrolment ratio (%) of Secondary schools in Europe(developing only) to that in Heavily indebted poor countries?
Offer a very short reply. 5.91. What is the ratio of the Gross enrolment ratio (%) in Tertiary schools in Europe(developing only) to that in Heavily indebted poor countries?
Provide a succinct answer. 15.51. What is the ratio of the Gross enrolment ratio (%) of Pre-primary schools in European Union to that in Fragile and conflict affected situations?
Ensure brevity in your answer.  10.04. What is the ratio of the Gross enrolment ratio (%) of Primary schools in European Union to that in Fragile and conflict affected situations?
Your answer should be compact. 1.43. What is the ratio of the Gross enrolment ratio (%) of Secondary schools in European Union to that in Fragile and conflict affected situations?
Your answer should be compact. 3.85. What is the ratio of the Gross enrolment ratio (%) of Tertiary schools in European Union to that in Fragile and conflict affected situations?
Give a very brief answer. 5.78. What is the ratio of the Gross enrolment ratio (%) in Pre-primary schools in European Union to that in Heavily indebted poor countries?
Offer a very short reply. 11.05. What is the ratio of the Gross enrolment ratio (%) in Primary schools in European Union to that in Heavily indebted poor countries?
Ensure brevity in your answer.  1.73. What is the ratio of the Gross enrolment ratio (%) in Secondary schools in European Union to that in Heavily indebted poor countries?
Your answer should be very brief. 6.42. What is the ratio of the Gross enrolment ratio (%) in Tertiary schools in European Union to that in Heavily indebted poor countries?
Offer a terse response. 14.01. What is the ratio of the Gross enrolment ratio (%) of Pre-primary schools in Fragile and conflict affected situations to that in Heavily indebted poor countries?
Provide a short and direct response. 1.1. What is the ratio of the Gross enrolment ratio (%) in Primary schools in Fragile and conflict affected situations to that in Heavily indebted poor countries?
Offer a very short reply. 1.21. What is the ratio of the Gross enrolment ratio (%) of Secondary schools in Fragile and conflict affected situations to that in Heavily indebted poor countries?
Your answer should be very brief. 1.67. What is the ratio of the Gross enrolment ratio (%) in Tertiary schools in Fragile and conflict affected situations to that in Heavily indebted poor countries?
Your answer should be very brief. 2.42. What is the difference between the highest and the second highest Gross enrolment ratio (%) in Pre-primary schools?
Your answer should be compact. 10.72. What is the difference between the highest and the second highest Gross enrolment ratio (%) of Primary schools?
Your answer should be compact. 0.78. What is the difference between the highest and the second highest Gross enrolment ratio (%) in Secondary schools?
Ensure brevity in your answer.  0.05. What is the difference between the highest and the second highest Gross enrolment ratio (%) in Tertiary schools?
Give a very brief answer. 4.26. What is the difference between the highest and the lowest Gross enrolment ratio (%) of Pre-primary schools?
Your answer should be very brief. 75.95. What is the difference between the highest and the lowest Gross enrolment ratio (%) in Primary schools?
Keep it short and to the point. 43.49. What is the difference between the highest and the lowest Gross enrolment ratio (%) in Secondary schools?
Your answer should be very brief. 74.16. What is the difference between the highest and the lowest Gross enrolment ratio (%) in Tertiary schools?
Your answer should be compact. 27.53. 